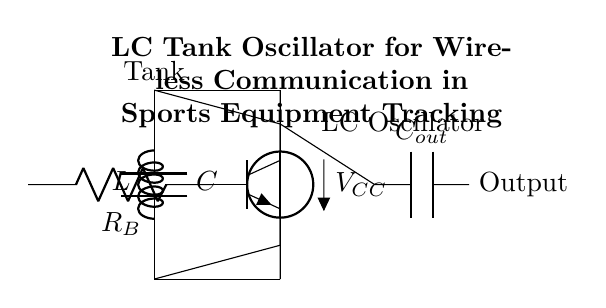What type of oscillator is depicted in this circuit? The circuit shows an LC tank oscillator, indicated by the presence of inductance (L) and capacitance (C) forming a resonant tank circuit. The title and the configuration support this classification.
Answer: LC tank oscillator What is the voltage supply value in this circuit? The circuit diagram includes a labeled voltage source (V) connected with the symbol indicating it is 5V, which represents the power supply for the oscillator.
Answer: 5V How is the transistor connected in the circuit? The NP transistor is connected in three ways: with its collector connected to the capacitor (C), its emitter connected to the ground (0V), and its base connected to the resistor (R) leading to the left side of the circuit. These connections define its role in the oscillator.
Answer: Collector to capacitor, emitter to ground, base to resistor What is the role of the capacitor labeled C in the tank circuit? The capacitor C in the tank circuit serves to store and release electrical energy, working in conjunction with the inductor L to create oscillations and enable resonance at a specific frequency, which is crucial for the oscillator function.
Answer: Store and release energy What happens to the output signal from the oscillator? The diagram indicates that the output capacitor (C_out) is connected to the collector of the transistor; therefore, the output signal is coupled through this capacitor, allowing AC signals to pass while blocking any DC components, which is typical for oscillator output stages.
Answer: Coupled through the output capacitor Which component determines the frequency of oscillation? The frequency of oscillation in an LC oscillator is determined by the combination of inductance (L) and capacitance (C) in the tank circuit using the formula: frequency equals one over two pi times the square root of LC. This direct relationship illustrates how L and C interact to set the oscillation frequency.
Answer: Inductor and capacitor 